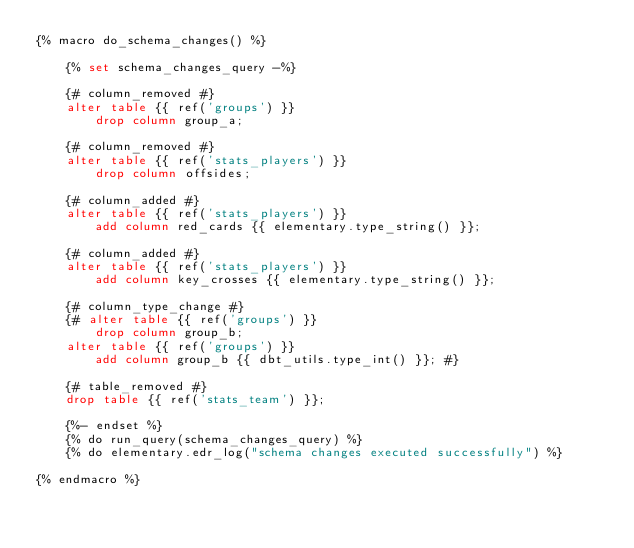<code> <loc_0><loc_0><loc_500><loc_500><_SQL_>{% macro do_schema_changes() %}

    {% set schema_changes_query -%}

    {# column_removed #}
    alter table {{ ref('groups') }}
        drop column group_a;

    {# column_removed #}
    alter table {{ ref('stats_players') }}
        drop column offsides;

    {# column_added #}
    alter table {{ ref('stats_players') }}
        add column red_cards {{ elementary.type_string() }};

    {# column_added #}
    alter table {{ ref('stats_players') }}
        add column key_crosses {{ elementary.type_string() }};

    {# column_type_change #}
    {# alter table {{ ref('groups') }}
        drop column group_b;
    alter table {{ ref('groups') }}
        add column group_b {{ dbt_utils.type_int() }}; #}

    {# table_removed #}
    drop table {{ ref('stats_team') }};

    {%- endset %}
    {% do run_query(schema_changes_query) %}
    {% do elementary.edr_log("schema changes executed successfully") %}

{% endmacro %}

</code> 